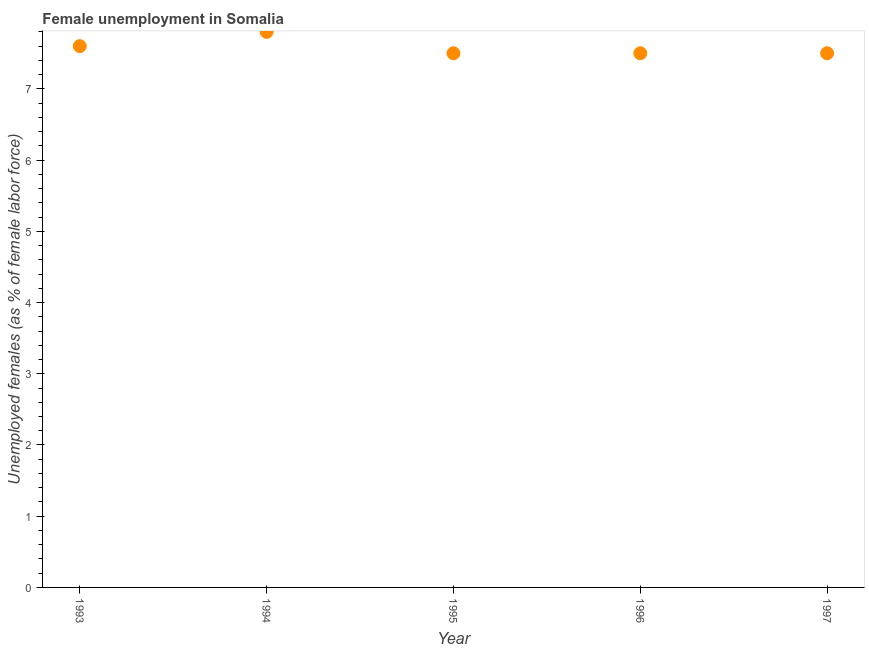What is the unemployed females population in 1996?
Make the answer very short. 7.5. Across all years, what is the maximum unemployed females population?
Give a very brief answer. 7.8. Across all years, what is the minimum unemployed females population?
Give a very brief answer. 7.5. What is the sum of the unemployed females population?
Offer a terse response. 37.9. What is the difference between the unemployed females population in 1993 and 1997?
Ensure brevity in your answer.  0.1. What is the average unemployed females population per year?
Provide a short and direct response. 7.58. What is the ratio of the unemployed females population in 1993 to that in 1995?
Offer a very short reply. 1.01. Is the difference between the unemployed females population in 1994 and 1997 greater than the difference between any two years?
Ensure brevity in your answer.  Yes. What is the difference between the highest and the second highest unemployed females population?
Offer a terse response. 0.2. What is the difference between the highest and the lowest unemployed females population?
Your answer should be very brief. 0.3. In how many years, is the unemployed females population greater than the average unemployed females population taken over all years?
Give a very brief answer. 2. What is the difference between two consecutive major ticks on the Y-axis?
Your answer should be very brief. 1. Are the values on the major ticks of Y-axis written in scientific E-notation?
Your answer should be very brief. No. What is the title of the graph?
Your answer should be compact. Female unemployment in Somalia. What is the label or title of the X-axis?
Offer a very short reply. Year. What is the label or title of the Y-axis?
Provide a succinct answer. Unemployed females (as % of female labor force). What is the Unemployed females (as % of female labor force) in 1993?
Ensure brevity in your answer.  7.6. What is the Unemployed females (as % of female labor force) in 1994?
Your response must be concise. 7.8. What is the Unemployed females (as % of female labor force) in 1995?
Offer a terse response. 7.5. What is the Unemployed females (as % of female labor force) in 1996?
Provide a short and direct response. 7.5. What is the Unemployed females (as % of female labor force) in 1997?
Offer a very short reply. 7.5. What is the difference between the Unemployed females (as % of female labor force) in 1994 and 1995?
Provide a succinct answer. 0.3. What is the difference between the Unemployed females (as % of female labor force) in 1994 and 1996?
Offer a very short reply. 0.3. What is the difference between the Unemployed females (as % of female labor force) in 1995 and 1997?
Offer a very short reply. 0. What is the ratio of the Unemployed females (as % of female labor force) in 1993 to that in 1994?
Your response must be concise. 0.97. What is the ratio of the Unemployed females (as % of female labor force) in 1993 to that in 1995?
Keep it short and to the point. 1.01. What is the ratio of the Unemployed females (as % of female labor force) in 1993 to that in 1996?
Give a very brief answer. 1.01. What is the ratio of the Unemployed females (as % of female labor force) in 1993 to that in 1997?
Keep it short and to the point. 1.01. What is the ratio of the Unemployed females (as % of female labor force) in 1994 to that in 1997?
Provide a succinct answer. 1.04. What is the ratio of the Unemployed females (as % of female labor force) in 1995 to that in 1997?
Provide a succinct answer. 1. 